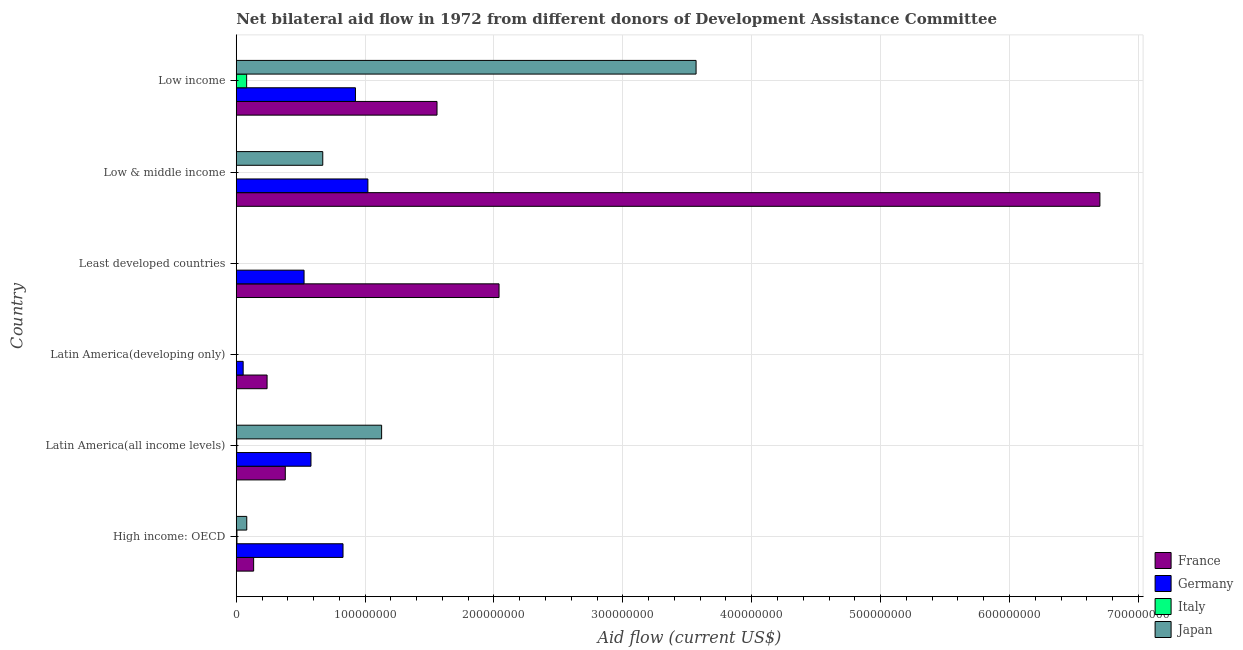Are the number of bars on each tick of the Y-axis equal?
Provide a succinct answer. No. How many bars are there on the 6th tick from the bottom?
Provide a succinct answer. 4. What is the label of the 6th group of bars from the top?
Your answer should be compact. High income: OECD. In how many cases, is the number of bars for a given country not equal to the number of legend labels?
Make the answer very short. 3. What is the amount of aid given by france in Latin America(developing only)?
Keep it short and to the point. 2.39e+07. Across all countries, what is the maximum amount of aid given by italy?
Offer a terse response. 8.06e+06. Across all countries, what is the minimum amount of aid given by germany?
Give a very brief answer. 5.36e+06. In which country was the amount of aid given by france maximum?
Make the answer very short. Low & middle income. What is the total amount of aid given by germany in the graph?
Make the answer very short. 3.93e+08. What is the difference between the amount of aid given by germany in Low & middle income and that in Low income?
Provide a succinct answer. 9.65e+06. What is the difference between the amount of aid given by japan in Least developed countries and the amount of aid given by italy in Latin America(developing only)?
Make the answer very short. -1.80e+05. What is the average amount of aid given by france per country?
Your response must be concise. 1.84e+08. What is the difference between the amount of aid given by france and amount of aid given by italy in Low income?
Your answer should be compact. 1.48e+08. What is the ratio of the amount of aid given by germany in Low & middle income to that in Low income?
Your answer should be compact. 1.1. Is the amount of aid given by france in High income: OECD less than that in Least developed countries?
Your answer should be compact. Yes. Is the difference between the amount of aid given by france in High income: OECD and Low income greater than the difference between the amount of aid given by germany in High income: OECD and Low income?
Provide a succinct answer. No. What is the difference between the highest and the second highest amount of aid given by france?
Offer a very short reply. 4.66e+08. What is the difference between the highest and the lowest amount of aid given by france?
Keep it short and to the point. 6.57e+08. Is it the case that in every country, the sum of the amount of aid given by italy and amount of aid given by japan is greater than the sum of amount of aid given by germany and amount of aid given by france?
Offer a terse response. No. Is it the case that in every country, the sum of the amount of aid given by france and amount of aid given by germany is greater than the amount of aid given by italy?
Provide a short and direct response. Yes. How many bars are there?
Provide a succinct answer. 20. How many countries are there in the graph?
Offer a terse response. 6. What is the difference between two consecutive major ticks on the X-axis?
Ensure brevity in your answer.  1.00e+08. Does the graph contain any zero values?
Make the answer very short. Yes. Does the graph contain grids?
Offer a very short reply. Yes. Where does the legend appear in the graph?
Offer a terse response. Bottom right. How many legend labels are there?
Offer a terse response. 4. What is the title of the graph?
Give a very brief answer. Net bilateral aid flow in 1972 from different donors of Development Assistance Committee. Does "Interest Payments" appear as one of the legend labels in the graph?
Offer a very short reply. No. What is the label or title of the X-axis?
Make the answer very short. Aid flow (current US$). What is the label or title of the Y-axis?
Make the answer very short. Country. What is the Aid flow (current US$) in France in High income: OECD?
Offer a very short reply. 1.35e+07. What is the Aid flow (current US$) of Germany in High income: OECD?
Your response must be concise. 8.28e+07. What is the Aid flow (current US$) of Italy in High income: OECD?
Give a very brief answer. 5.60e+05. What is the Aid flow (current US$) in Japan in High income: OECD?
Your response must be concise. 8.16e+06. What is the Aid flow (current US$) of France in Latin America(all income levels)?
Your response must be concise. 3.81e+07. What is the Aid flow (current US$) of Germany in Latin America(all income levels)?
Your response must be concise. 5.80e+07. What is the Aid flow (current US$) of Italy in Latin America(all income levels)?
Keep it short and to the point. 3.80e+05. What is the Aid flow (current US$) in Japan in Latin America(all income levels)?
Keep it short and to the point. 1.13e+08. What is the Aid flow (current US$) in France in Latin America(developing only)?
Provide a short and direct response. 2.39e+07. What is the Aid flow (current US$) in Germany in Latin America(developing only)?
Make the answer very short. 5.36e+06. What is the Aid flow (current US$) in Italy in Latin America(developing only)?
Your answer should be very brief. 1.80e+05. What is the Aid flow (current US$) of Japan in Latin America(developing only)?
Ensure brevity in your answer.  0. What is the Aid flow (current US$) in France in Least developed countries?
Your answer should be compact. 2.04e+08. What is the Aid flow (current US$) of Germany in Least developed countries?
Ensure brevity in your answer.  5.26e+07. What is the Aid flow (current US$) in Italy in Least developed countries?
Make the answer very short. 0. What is the Aid flow (current US$) of Japan in Least developed countries?
Provide a succinct answer. 0. What is the Aid flow (current US$) of France in Low & middle income?
Offer a very short reply. 6.70e+08. What is the Aid flow (current US$) of Germany in Low & middle income?
Your answer should be very brief. 1.02e+08. What is the Aid flow (current US$) of Italy in Low & middle income?
Offer a very short reply. 0. What is the Aid flow (current US$) of Japan in Low & middle income?
Offer a very short reply. 6.71e+07. What is the Aid flow (current US$) in France in Low income?
Give a very brief answer. 1.56e+08. What is the Aid flow (current US$) in Germany in Low income?
Offer a terse response. 9.25e+07. What is the Aid flow (current US$) in Italy in Low income?
Give a very brief answer. 8.06e+06. What is the Aid flow (current US$) of Japan in Low income?
Offer a very short reply. 3.57e+08. Across all countries, what is the maximum Aid flow (current US$) of France?
Your response must be concise. 6.70e+08. Across all countries, what is the maximum Aid flow (current US$) in Germany?
Ensure brevity in your answer.  1.02e+08. Across all countries, what is the maximum Aid flow (current US$) in Italy?
Give a very brief answer. 8.06e+06. Across all countries, what is the maximum Aid flow (current US$) in Japan?
Your answer should be compact. 3.57e+08. Across all countries, what is the minimum Aid flow (current US$) in France?
Offer a terse response. 1.35e+07. Across all countries, what is the minimum Aid flow (current US$) in Germany?
Make the answer very short. 5.36e+06. Across all countries, what is the minimum Aid flow (current US$) of Italy?
Give a very brief answer. 0. What is the total Aid flow (current US$) in France in the graph?
Keep it short and to the point. 1.11e+09. What is the total Aid flow (current US$) of Germany in the graph?
Provide a succinct answer. 3.93e+08. What is the total Aid flow (current US$) in Italy in the graph?
Make the answer very short. 9.18e+06. What is the total Aid flow (current US$) in Japan in the graph?
Your answer should be compact. 5.45e+08. What is the difference between the Aid flow (current US$) in France in High income: OECD and that in Latin America(all income levels)?
Offer a very short reply. -2.46e+07. What is the difference between the Aid flow (current US$) of Germany in High income: OECD and that in Latin America(all income levels)?
Provide a succinct answer. 2.49e+07. What is the difference between the Aid flow (current US$) in Italy in High income: OECD and that in Latin America(all income levels)?
Keep it short and to the point. 1.80e+05. What is the difference between the Aid flow (current US$) of Japan in High income: OECD and that in Latin America(all income levels)?
Ensure brevity in your answer.  -1.05e+08. What is the difference between the Aid flow (current US$) in France in High income: OECD and that in Latin America(developing only)?
Give a very brief answer. -1.04e+07. What is the difference between the Aid flow (current US$) of Germany in High income: OECD and that in Latin America(developing only)?
Offer a terse response. 7.75e+07. What is the difference between the Aid flow (current US$) of Italy in High income: OECD and that in Latin America(developing only)?
Give a very brief answer. 3.80e+05. What is the difference between the Aid flow (current US$) in France in High income: OECD and that in Least developed countries?
Offer a terse response. -1.90e+08. What is the difference between the Aid flow (current US$) in Germany in High income: OECD and that in Least developed countries?
Keep it short and to the point. 3.02e+07. What is the difference between the Aid flow (current US$) of France in High income: OECD and that in Low & middle income?
Keep it short and to the point. -6.57e+08. What is the difference between the Aid flow (current US$) of Germany in High income: OECD and that in Low & middle income?
Give a very brief answer. -1.93e+07. What is the difference between the Aid flow (current US$) of Japan in High income: OECD and that in Low & middle income?
Your response must be concise. -5.90e+07. What is the difference between the Aid flow (current US$) in France in High income: OECD and that in Low income?
Offer a very short reply. -1.42e+08. What is the difference between the Aid flow (current US$) of Germany in High income: OECD and that in Low income?
Provide a short and direct response. -9.65e+06. What is the difference between the Aid flow (current US$) of Italy in High income: OECD and that in Low income?
Your response must be concise. -7.50e+06. What is the difference between the Aid flow (current US$) in Japan in High income: OECD and that in Low income?
Give a very brief answer. -3.49e+08. What is the difference between the Aid flow (current US$) in France in Latin America(all income levels) and that in Latin America(developing only)?
Keep it short and to the point. 1.41e+07. What is the difference between the Aid flow (current US$) in Germany in Latin America(all income levels) and that in Latin America(developing only)?
Your answer should be compact. 5.26e+07. What is the difference between the Aid flow (current US$) of Italy in Latin America(all income levels) and that in Latin America(developing only)?
Provide a succinct answer. 2.00e+05. What is the difference between the Aid flow (current US$) in France in Latin America(all income levels) and that in Least developed countries?
Your answer should be compact. -1.66e+08. What is the difference between the Aid flow (current US$) in Germany in Latin America(all income levels) and that in Least developed countries?
Keep it short and to the point. 5.36e+06. What is the difference between the Aid flow (current US$) in France in Latin America(all income levels) and that in Low & middle income?
Keep it short and to the point. -6.32e+08. What is the difference between the Aid flow (current US$) of Germany in Latin America(all income levels) and that in Low & middle income?
Your answer should be compact. -4.42e+07. What is the difference between the Aid flow (current US$) in Japan in Latin America(all income levels) and that in Low & middle income?
Provide a succinct answer. 4.57e+07. What is the difference between the Aid flow (current US$) in France in Latin America(all income levels) and that in Low income?
Provide a short and direct response. -1.18e+08. What is the difference between the Aid flow (current US$) of Germany in Latin America(all income levels) and that in Low income?
Give a very brief answer. -3.45e+07. What is the difference between the Aid flow (current US$) of Italy in Latin America(all income levels) and that in Low income?
Provide a succinct answer. -7.68e+06. What is the difference between the Aid flow (current US$) of Japan in Latin America(all income levels) and that in Low income?
Your answer should be very brief. -2.44e+08. What is the difference between the Aid flow (current US$) of France in Latin America(developing only) and that in Least developed countries?
Ensure brevity in your answer.  -1.80e+08. What is the difference between the Aid flow (current US$) of Germany in Latin America(developing only) and that in Least developed countries?
Give a very brief answer. -4.73e+07. What is the difference between the Aid flow (current US$) of France in Latin America(developing only) and that in Low & middle income?
Your answer should be very brief. -6.46e+08. What is the difference between the Aid flow (current US$) in Germany in Latin America(developing only) and that in Low & middle income?
Make the answer very short. -9.68e+07. What is the difference between the Aid flow (current US$) in France in Latin America(developing only) and that in Low income?
Give a very brief answer. -1.32e+08. What is the difference between the Aid flow (current US$) in Germany in Latin America(developing only) and that in Low income?
Make the answer very short. -8.71e+07. What is the difference between the Aid flow (current US$) of Italy in Latin America(developing only) and that in Low income?
Give a very brief answer. -7.88e+06. What is the difference between the Aid flow (current US$) in France in Least developed countries and that in Low & middle income?
Offer a terse response. -4.66e+08. What is the difference between the Aid flow (current US$) in Germany in Least developed countries and that in Low & middle income?
Your answer should be very brief. -4.95e+07. What is the difference between the Aid flow (current US$) in France in Least developed countries and that in Low income?
Keep it short and to the point. 4.81e+07. What is the difference between the Aid flow (current US$) in Germany in Least developed countries and that in Low income?
Provide a short and direct response. -3.99e+07. What is the difference between the Aid flow (current US$) of France in Low & middle income and that in Low income?
Offer a very short reply. 5.14e+08. What is the difference between the Aid flow (current US$) in Germany in Low & middle income and that in Low income?
Offer a terse response. 9.65e+06. What is the difference between the Aid flow (current US$) in Japan in Low & middle income and that in Low income?
Your answer should be compact. -2.90e+08. What is the difference between the Aid flow (current US$) in France in High income: OECD and the Aid flow (current US$) in Germany in Latin America(all income levels)?
Give a very brief answer. -4.45e+07. What is the difference between the Aid flow (current US$) in France in High income: OECD and the Aid flow (current US$) in Italy in Latin America(all income levels)?
Provide a short and direct response. 1.31e+07. What is the difference between the Aid flow (current US$) of France in High income: OECD and the Aid flow (current US$) of Japan in Latin America(all income levels)?
Your response must be concise. -9.93e+07. What is the difference between the Aid flow (current US$) of Germany in High income: OECD and the Aid flow (current US$) of Italy in Latin America(all income levels)?
Offer a very short reply. 8.25e+07. What is the difference between the Aid flow (current US$) in Germany in High income: OECD and the Aid flow (current US$) in Japan in Latin America(all income levels)?
Provide a succinct answer. -3.00e+07. What is the difference between the Aid flow (current US$) in Italy in High income: OECD and the Aid flow (current US$) in Japan in Latin America(all income levels)?
Give a very brief answer. -1.12e+08. What is the difference between the Aid flow (current US$) in France in High income: OECD and the Aid flow (current US$) in Germany in Latin America(developing only)?
Keep it short and to the point. 8.13e+06. What is the difference between the Aid flow (current US$) of France in High income: OECD and the Aid flow (current US$) of Italy in Latin America(developing only)?
Offer a terse response. 1.33e+07. What is the difference between the Aid flow (current US$) of Germany in High income: OECD and the Aid flow (current US$) of Italy in Latin America(developing only)?
Offer a terse response. 8.27e+07. What is the difference between the Aid flow (current US$) in France in High income: OECD and the Aid flow (current US$) in Germany in Least developed countries?
Give a very brief answer. -3.91e+07. What is the difference between the Aid flow (current US$) of France in High income: OECD and the Aid flow (current US$) of Germany in Low & middle income?
Offer a very short reply. -8.87e+07. What is the difference between the Aid flow (current US$) in France in High income: OECD and the Aid flow (current US$) in Japan in Low & middle income?
Provide a short and direct response. -5.36e+07. What is the difference between the Aid flow (current US$) of Germany in High income: OECD and the Aid flow (current US$) of Japan in Low & middle income?
Offer a very short reply. 1.57e+07. What is the difference between the Aid flow (current US$) of Italy in High income: OECD and the Aid flow (current US$) of Japan in Low & middle income?
Make the answer very short. -6.66e+07. What is the difference between the Aid flow (current US$) of France in High income: OECD and the Aid flow (current US$) of Germany in Low income?
Your answer should be compact. -7.90e+07. What is the difference between the Aid flow (current US$) of France in High income: OECD and the Aid flow (current US$) of Italy in Low income?
Your answer should be very brief. 5.43e+06. What is the difference between the Aid flow (current US$) of France in High income: OECD and the Aid flow (current US$) of Japan in Low income?
Your answer should be very brief. -3.43e+08. What is the difference between the Aid flow (current US$) of Germany in High income: OECD and the Aid flow (current US$) of Italy in Low income?
Give a very brief answer. 7.48e+07. What is the difference between the Aid flow (current US$) of Germany in High income: OECD and the Aid flow (current US$) of Japan in Low income?
Provide a short and direct response. -2.74e+08. What is the difference between the Aid flow (current US$) in Italy in High income: OECD and the Aid flow (current US$) in Japan in Low income?
Offer a very short reply. -3.56e+08. What is the difference between the Aid flow (current US$) of France in Latin America(all income levels) and the Aid flow (current US$) of Germany in Latin America(developing only)?
Ensure brevity in your answer.  3.27e+07. What is the difference between the Aid flow (current US$) of France in Latin America(all income levels) and the Aid flow (current US$) of Italy in Latin America(developing only)?
Your answer should be compact. 3.79e+07. What is the difference between the Aid flow (current US$) in Germany in Latin America(all income levels) and the Aid flow (current US$) in Italy in Latin America(developing only)?
Give a very brief answer. 5.78e+07. What is the difference between the Aid flow (current US$) in France in Latin America(all income levels) and the Aid flow (current US$) in Germany in Least developed countries?
Your answer should be very brief. -1.46e+07. What is the difference between the Aid flow (current US$) in France in Latin America(all income levels) and the Aid flow (current US$) in Germany in Low & middle income?
Offer a terse response. -6.41e+07. What is the difference between the Aid flow (current US$) in France in Latin America(all income levels) and the Aid flow (current US$) in Japan in Low & middle income?
Give a very brief answer. -2.91e+07. What is the difference between the Aid flow (current US$) in Germany in Latin America(all income levels) and the Aid flow (current US$) in Japan in Low & middle income?
Your answer should be very brief. -9.15e+06. What is the difference between the Aid flow (current US$) of Italy in Latin America(all income levels) and the Aid flow (current US$) of Japan in Low & middle income?
Make the answer very short. -6.68e+07. What is the difference between the Aid flow (current US$) of France in Latin America(all income levels) and the Aid flow (current US$) of Germany in Low income?
Provide a short and direct response. -5.44e+07. What is the difference between the Aid flow (current US$) in France in Latin America(all income levels) and the Aid flow (current US$) in Italy in Low income?
Make the answer very short. 3.00e+07. What is the difference between the Aid flow (current US$) in France in Latin America(all income levels) and the Aid flow (current US$) in Japan in Low income?
Provide a short and direct response. -3.19e+08. What is the difference between the Aid flow (current US$) of Germany in Latin America(all income levels) and the Aid flow (current US$) of Italy in Low income?
Provide a short and direct response. 4.99e+07. What is the difference between the Aid flow (current US$) in Germany in Latin America(all income levels) and the Aid flow (current US$) in Japan in Low income?
Keep it short and to the point. -2.99e+08. What is the difference between the Aid flow (current US$) in Italy in Latin America(all income levels) and the Aid flow (current US$) in Japan in Low income?
Make the answer very short. -3.56e+08. What is the difference between the Aid flow (current US$) in France in Latin America(developing only) and the Aid flow (current US$) in Germany in Least developed countries?
Make the answer very short. -2.87e+07. What is the difference between the Aid flow (current US$) of France in Latin America(developing only) and the Aid flow (current US$) of Germany in Low & middle income?
Keep it short and to the point. -7.82e+07. What is the difference between the Aid flow (current US$) in France in Latin America(developing only) and the Aid flow (current US$) in Japan in Low & middle income?
Your response must be concise. -4.32e+07. What is the difference between the Aid flow (current US$) in Germany in Latin America(developing only) and the Aid flow (current US$) in Japan in Low & middle income?
Your answer should be compact. -6.18e+07. What is the difference between the Aid flow (current US$) in Italy in Latin America(developing only) and the Aid flow (current US$) in Japan in Low & middle income?
Your answer should be very brief. -6.70e+07. What is the difference between the Aid flow (current US$) of France in Latin America(developing only) and the Aid flow (current US$) of Germany in Low income?
Your answer should be very brief. -6.86e+07. What is the difference between the Aid flow (current US$) in France in Latin America(developing only) and the Aid flow (current US$) in Italy in Low income?
Make the answer very short. 1.59e+07. What is the difference between the Aid flow (current US$) in France in Latin America(developing only) and the Aid flow (current US$) in Japan in Low income?
Your answer should be very brief. -3.33e+08. What is the difference between the Aid flow (current US$) of Germany in Latin America(developing only) and the Aid flow (current US$) of Italy in Low income?
Keep it short and to the point. -2.70e+06. What is the difference between the Aid flow (current US$) of Germany in Latin America(developing only) and the Aid flow (current US$) of Japan in Low income?
Offer a terse response. -3.51e+08. What is the difference between the Aid flow (current US$) of Italy in Latin America(developing only) and the Aid flow (current US$) of Japan in Low income?
Your answer should be very brief. -3.57e+08. What is the difference between the Aid flow (current US$) of France in Least developed countries and the Aid flow (current US$) of Germany in Low & middle income?
Your answer should be very brief. 1.02e+08. What is the difference between the Aid flow (current US$) in France in Least developed countries and the Aid flow (current US$) in Japan in Low & middle income?
Make the answer very short. 1.37e+08. What is the difference between the Aid flow (current US$) in Germany in Least developed countries and the Aid flow (current US$) in Japan in Low & middle income?
Your answer should be compact. -1.45e+07. What is the difference between the Aid flow (current US$) in France in Least developed countries and the Aid flow (current US$) in Germany in Low income?
Give a very brief answer. 1.11e+08. What is the difference between the Aid flow (current US$) of France in Least developed countries and the Aid flow (current US$) of Italy in Low income?
Ensure brevity in your answer.  1.96e+08. What is the difference between the Aid flow (current US$) in France in Least developed countries and the Aid flow (current US$) in Japan in Low income?
Offer a very short reply. -1.53e+08. What is the difference between the Aid flow (current US$) in Germany in Least developed countries and the Aid flow (current US$) in Italy in Low income?
Offer a very short reply. 4.46e+07. What is the difference between the Aid flow (current US$) in Germany in Least developed countries and the Aid flow (current US$) in Japan in Low income?
Ensure brevity in your answer.  -3.04e+08. What is the difference between the Aid flow (current US$) of France in Low & middle income and the Aid flow (current US$) of Germany in Low income?
Provide a succinct answer. 5.78e+08. What is the difference between the Aid flow (current US$) in France in Low & middle income and the Aid flow (current US$) in Italy in Low income?
Provide a succinct answer. 6.62e+08. What is the difference between the Aid flow (current US$) in France in Low & middle income and the Aid flow (current US$) in Japan in Low income?
Your answer should be very brief. 3.13e+08. What is the difference between the Aid flow (current US$) in Germany in Low & middle income and the Aid flow (current US$) in Italy in Low income?
Provide a succinct answer. 9.41e+07. What is the difference between the Aid flow (current US$) of Germany in Low & middle income and the Aid flow (current US$) of Japan in Low income?
Offer a very short reply. -2.55e+08. What is the average Aid flow (current US$) of France per country?
Give a very brief answer. 1.84e+08. What is the average Aid flow (current US$) of Germany per country?
Your answer should be very brief. 6.56e+07. What is the average Aid flow (current US$) of Italy per country?
Keep it short and to the point. 1.53e+06. What is the average Aid flow (current US$) of Japan per country?
Your answer should be compact. 9.08e+07. What is the difference between the Aid flow (current US$) of France and Aid flow (current US$) of Germany in High income: OECD?
Your answer should be very brief. -6.94e+07. What is the difference between the Aid flow (current US$) in France and Aid flow (current US$) in Italy in High income: OECD?
Provide a succinct answer. 1.29e+07. What is the difference between the Aid flow (current US$) in France and Aid flow (current US$) in Japan in High income: OECD?
Make the answer very short. 5.33e+06. What is the difference between the Aid flow (current US$) in Germany and Aid flow (current US$) in Italy in High income: OECD?
Ensure brevity in your answer.  8.23e+07. What is the difference between the Aid flow (current US$) of Germany and Aid flow (current US$) of Japan in High income: OECD?
Make the answer very short. 7.47e+07. What is the difference between the Aid flow (current US$) in Italy and Aid flow (current US$) in Japan in High income: OECD?
Provide a short and direct response. -7.60e+06. What is the difference between the Aid flow (current US$) in France and Aid flow (current US$) in Germany in Latin America(all income levels)?
Your answer should be compact. -1.99e+07. What is the difference between the Aid flow (current US$) in France and Aid flow (current US$) in Italy in Latin America(all income levels)?
Provide a succinct answer. 3.77e+07. What is the difference between the Aid flow (current US$) of France and Aid flow (current US$) of Japan in Latin America(all income levels)?
Your answer should be very brief. -7.48e+07. What is the difference between the Aid flow (current US$) in Germany and Aid flow (current US$) in Italy in Latin America(all income levels)?
Make the answer very short. 5.76e+07. What is the difference between the Aid flow (current US$) of Germany and Aid flow (current US$) of Japan in Latin America(all income levels)?
Offer a terse response. -5.48e+07. What is the difference between the Aid flow (current US$) in Italy and Aid flow (current US$) in Japan in Latin America(all income levels)?
Provide a succinct answer. -1.12e+08. What is the difference between the Aid flow (current US$) of France and Aid flow (current US$) of Germany in Latin America(developing only)?
Keep it short and to the point. 1.86e+07. What is the difference between the Aid flow (current US$) in France and Aid flow (current US$) in Italy in Latin America(developing only)?
Your answer should be very brief. 2.37e+07. What is the difference between the Aid flow (current US$) in Germany and Aid flow (current US$) in Italy in Latin America(developing only)?
Provide a succinct answer. 5.18e+06. What is the difference between the Aid flow (current US$) in France and Aid flow (current US$) in Germany in Least developed countries?
Keep it short and to the point. 1.51e+08. What is the difference between the Aid flow (current US$) of France and Aid flow (current US$) of Germany in Low & middle income?
Provide a succinct answer. 5.68e+08. What is the difference between the Aid flow (current US$) of France and Aid flow (current US$) of Japan in Low & middle income?
Ensure brevity in your answer.  6.03e+08. What is the difference between the Aid flow (current US$) of Germany and Aid flow (current US$) of Japan in Low & middle income?
Your answer should be very brief. 3.50e+07. What is the difference between the Aid flow (current US$) of France and Aid flow (current US$) of Germany in Low income?
Ensure brevity in your answer.  6.33e+07. What is the difference between the Aid flow (current US$) of France and Aid flow (current US$) of Italy in Low income?
Offer a very short reply. 1.48e+08. What is the difference between the Aid flow (current US$) in France and Aid flow (current US$) in Japan in Low income?
Give a very brief answer. -2.01e+08. What is the difference between the Aid flow (current US$) in Germany and Aid flow (current US$) in Italy in Low income?
Your answer should be compact. 8.44e+07. What is the difference between the Aid flow (current US$) in Germany and Aid flow (current US$) in Japan in Low income?
Give a very brief answer. -2.64e+08. What is the difference between the Aid flow (current US$) of Italy and Aid flow (current US$) of Japan in Low income?
Offer a very short reply. -3.49e+08. What is the ratio of the Aid flow (current US$) of France in High income: OECD to that in Latin America(all income levels)?
Make the answer very short. 0.35. What is the ratio of the Aid flow (current US$) in Germany in High income: OECD to that in Latin America(all income levels)?
Your answer should be very brief. 1.43. What is the ratio of the Aid flow (current US$) of Italy in High income: OECD to that in Latin America(all income levels)?
Make the answer very short. 1.47. What is the ratio of the Aid flow (current US$) of Japan in High income: OECD to that in Latin America(all income levels)?
Provide a succinct answer. 0.07. What is the ratio of the Aid flow (current US$) of France in High income: OECD to that in Latin America(developing only)?
Ensure brevity in your answer.  0.56. What is the ratio of the Aid flow (current US$) of Germany in High income: OECD to that in Latin America(developing only)?
Make the answer very short. 15.46. What is the ratio of the Aid flow (current US$) of Italy in High income: OECD to that in Latin America(developing only)?
Provide a succinct answer. 3.11. What is the ratio of the Aid flow (current US$) of France in High income: OECD to that in Least developed countries?
Offer a terse response. 0.07. What is the ratio of the Aid flow (current US$) in Germany in High income: OECD to that in Least developed countries?
Your answer should be compact. 1.57. What is the ratio of the Aid flow (current US$) in France in High income: OECD to that in Low & middle income?
Offer a terse response. 0.02. What is the ratio of the Aid flow (current US$) in Germany in High income: OECD to that in Low & middle income?
Keep it short and to the point. 0.81. What is the ratio of the Aid flow (current US$) of Japan in High income: OECD to that in Low & middle income?
Keep it short and to the point. 0.12. What is the ratio of the Aid flow (current US$) in France in High income: OECD to that in Low income?
Give a very brief answer. 0.09. What is the ratio of the Aid flow (current US$) in Germany in High income: OECD to that in Low income?
Offer a terse response. 0.9. What is the ratio of the Aid flow (current US$) of Italy in High income: OECD to that in Low income?
Provide a succinct answer. 0.07. What is the ratio of the Aid flow (current US$) of Japan in High income: OECD to that in Low income?
Provide a short and direct response. 0.02. What is the ratio of the Aid flow (current US$) of France in Latin America(all income levels) to that in Latin America(developing only)?
Offer a very short reply. 1.59. What is the ratio of the Aid flow (current US$) in Germany in Latin America(all income levels) to that in Latin America(developing only)?
Provide a succinct answer. 10.82. What is the ratio of the Aid flow (current US$) of Italy in Latin America(all income levels) to that in Latin America(developing only)?
Your answer should be compact. 2.11. What is the ratio of the Aid flow (current US$) of France in Latin America(all income levels) to that in Least developed countries?
Ensure brevity in your answer.  0.19. What is the ratio of the Aid flow (current US$) of Germany in Latin America(all income levels) to that in Least developed countries?
Offer a very short reply. 1.1. What is the ratio of the Aid flow (current US$) in France in Latin America(all income levels) to that in Low & middle income?
Provide a short and direct response. 0.06. What is the ratio of the Aid flow (current US$) in Germany in Latin America(all income levels) to that in Low & middle income?
Provide a short and direct response. 0.57. What is the ratio of the Aid flow (current US$) in Japan in Latin America(all income levels) to that in Low & middle income?
Offer a terse response. 1.68. What is the ratio of the Aid flow (current US$) of France in Latin America(all income levels) to that in Low income?
Give a very brief answer. 0.24. What is the ratio of the Aid flow (current US$) in Germany in Latin America(all income levels) to that in Low income?
Your answer should be compact. 0.63. What is the ratio of the Aid flow (current US$) in Italy in Latin America(all income levels) to that in Low income?
Offer a terse response. 0.05. What is the ratio of the Aid flow (current US$) of Japan in Latin America(all income levels) to that in Low income?
Provide a short and direct response. 0.32. What is the ratio of the Aid flow (current US$) in France in Latin America(developing only) to that in Least developed countries?
Offer a very short reply. 0.12. What is the ratio of the Aid flow (current US$) of Germany in Latin America(developing only) to that in Least developed countries?
Offer a very short reply. 0.1. What is the ratio of the Aid flow (current US$) in France in Latin America(developing only) to that in Low & middle income?
Your answer should be compact. 0.04. What is the ratio of the Aid flow (current US$) of Germany in Latin America(developing only) to that in Low & middle income?
Make the answer very short. 0.05. What is the ratio of the Aid flow (current US$) in France in Latin America(developing only) to that in Low income?
Offer a very short reply. 0.15. What is the ratio of the Aid flow (current US$) of Germany in Latin America(developing only) to that in Low income?
Provide a succinct answer. 0.06. What is the ratio of the Aid flow (current US$) of Italy in Latin America(developing only) to that in Low income?
Offer a terse response. 0.02. What is the ratio of the Aid flow (current US$) of France in Least developed countries to that in Low & middle income?
Offer a very short reply. 0.3. What is the ratio of the Aid flow (current US$) of Germany in Least developed countries to that in Low & middle income?
Your answer should be very brief. 0.52. What is the ratio of the Aid flow (current US$) in France in Least developed countries to that in Low income?
Your answer should be very brief. 1.31. What is the ratio of the Aid flow (current US$) in Germany in Least developed countries to that in Low income?
Your answer should be compact. 0.57. What is the ratio of the Aid flow (current US$) of France in Low & middle income to that in Low income?
Make the answer very short. 4.3. What is the ratio of the Aid flow (current US$) in Germany in Low & middle income to that in Low income?
Your response must be concise. 1.1. What is the ratio of the Aid flow (current US$) in Japan in Low & middle income to that in Low income?
Give a very brief answer. 0.19. What is the difference between the highest and the second highest Aid flow (current US$) of France?
Provide a short and direct response. 4.66e+08. What is the difference between the highest and the second highest Aid flow (current US$) of Germany?
Your answer should be compact. 9.65e+06. What is the difference between the highest and the second highest Aid flow (current US$) in Italy?
Your answer should be very brief. 7.50e+06. What is the difference between the highest and the second highest Aid flow (current US$) of Japan?
Your answer should be very brief. 2.44e+08. What is the difference between the highest and the lowest Aid flow (current US$) in France?
Make the answer very short. 6.57e+08. What is the difference between the highest and the lowest Aid flow (current US$) of Germany?
Offer a terse response. 9.68e+07. What is the difference between the highest and the lowest Aid flow (current US$) in Italy?
Your answer should be compact. 8.06e+06. What is the difference between the highest and the lowest Aid flow (current US$) of Japan?
Your answer should be very brief. 3.57e+08. 